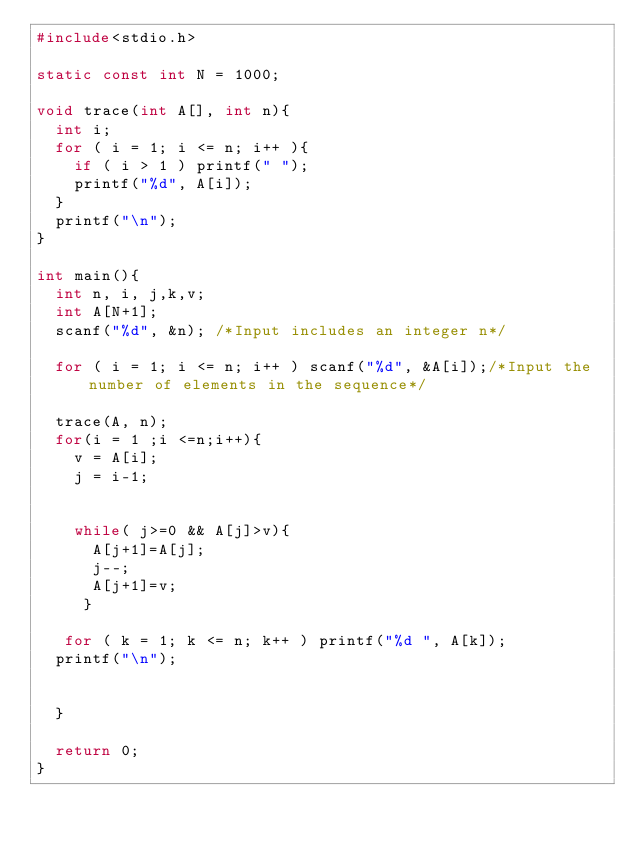<code> <loc_0><loc_0><loc_500><loc_500><_C_>#include<stdio.h>

static const int N = 1000;

void trace(int A[], int n){
  int i;
  for ( i = 1; i <= n; i++ ){
    if ( i > 1 ) printf(" ");
    printf("%d", A[i]);
  }
  printf("\n");
}

int main(){
  int n, i, j,k,v;
  int A[N+1];
  scanf("%d", &n); /*Input includes an integer n*/

  for ( i = 1; i <= n; i++ ) scanf("%d", &A[i]);/*Input the number of elements in the sequence*/
  
  trace(A, n);
  for(i = 1 ;i <=n;i++){
    v = A[i];
    j = i-1;

   
    while( j>=0 && A[j]>v){
      A[j+1]=A[j];
      j--;
      A[j+1]=v;
     }

   for ( k = 1; k <= n; k++ ) printf("%d ", A[k]);
  printf("\n");
    
  
  }
    
  return 0;
}</code> 